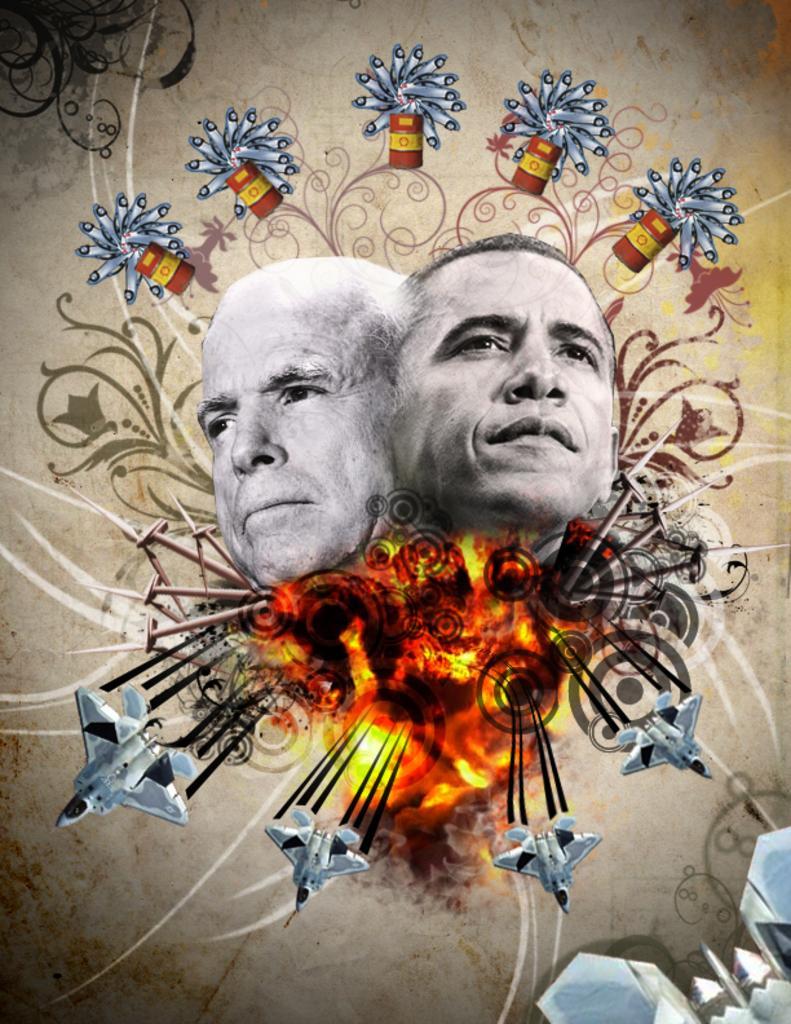How would you summarize this image in a sentence or two? As we can see in the image there is a banner. On banner there are jet planes, fire and two people faces. 